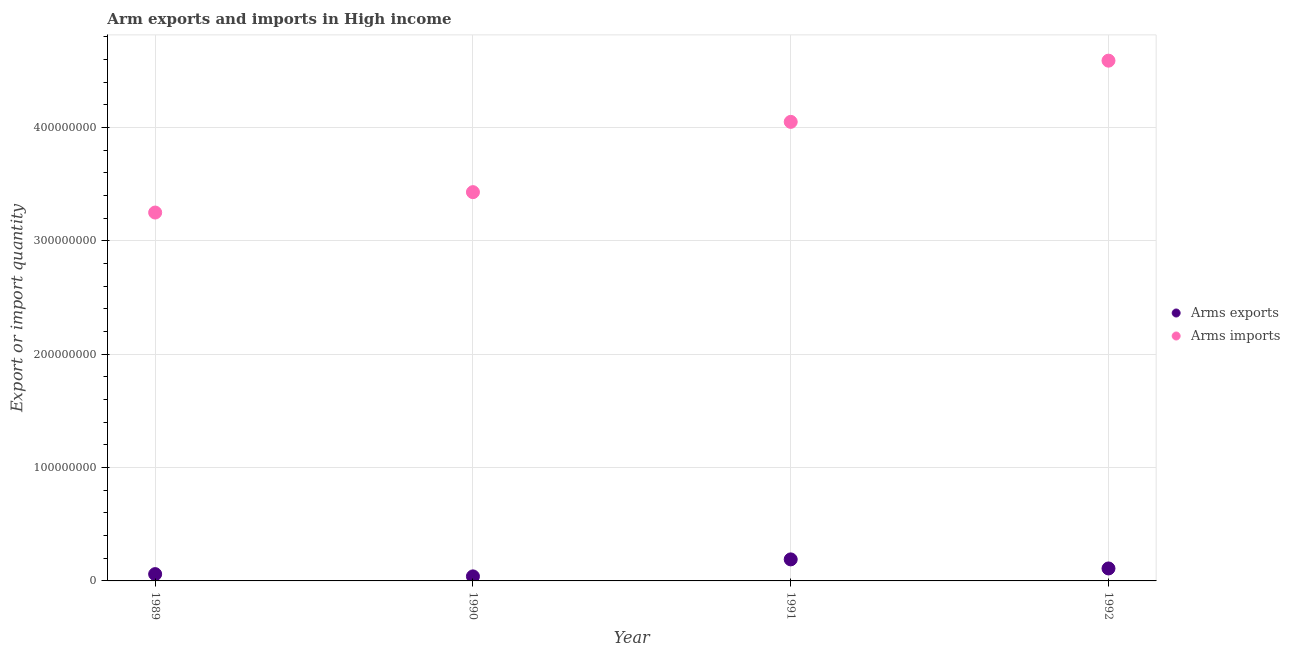Is the number of dotlines equal to the number of legend labels?
Offer a terse response. Yes. What is the arms imports in 1990?
Provide a succinct answer. 3.43e+08. Across all years, what is the maximum arms imports?
Offer a terse response. 4.59e+08. Across all years, what is the minimum arms imports?
Your answer should be very brief. 3.25e+08. In which year was the arms exports minimum?
Provide a short and direct response. 1990. What is the total arms imports in the graph?
Offer a very short reply. 1.53e+09. What is the difference between the arms imports in 1991 and that in 1992?
Your answer should be very brief. -5.40e+07. What is the difference between the arms exports in 1989 and the arms imports in 1992?
Offer a very short reply. -4.53e+08. What is the average arms imports per year?
Keep it short and to the point. 3.83e+08. In the year 1991, what is the difference between the arms imports and arms exports?
Keep it short and to the point. 3.86e+08. In how many years, is the arms exports greater than 340000000?
Give a very brief answer. 0. What is the ratio of the arms imports in 1989 to that in 1992?
Provide a short and direct response. 0.71. Is the arms exports in 1990 less than that in 1991?
Provide a succinct answer. Yes. Is the difference between the arms exports in 1989 and 1990 greater than the difference between the arms imports in 1989 and 1990?
Give a very brief answer. Yes. What is the difference between the highest and the lowest arms imports?
Keep it short and to the point. 1.34e+08. Does the arms imports monotonically increase over the years?
Your answer should be very brief. Yes. What is the difference between two consecutive major ticks on the Y-axis?
Your answer should be compact. 1.00e+08. Are the values on the major ticks of Y-axis written in scientific E-notation?
Give a very brief answer. No. Does the graph contain grids?
Your answer should be very brief. Yes. How are the legend labels stacked?
Provide a succinct answer. Vertical. What is the title of the graph?
Offer a terse response. Arm exports and imports in High income. Does "Food" appear as one of the legend labels in the graph?
Provide a succinct answer. No. What is the label or title of the Y-axis?
Your response must be concise. Export or import quantity. What is the Export or import quantity of Arms imports in 1989?
Make the answer very short. 3.25e+08. What is the Export or import quantity of Arms imports in 1990?
Ensure brevity in your answer.  3.43e+08. What is the Export or import quantity in Arms exports in 1991?
Offer a very short reply. 1.90e+07. What is the Export or import quantity in Arms imports in 1991?
Keep it short and to the point. 4.05e+08. What is the Export or import quantity of Arms exports in 1992?
Your response must be concise. 1.10e+07. What is the Export or import quantity of Arms imports in 1992?
Offer a terse response. 4.59e+08. Across all years, what is the maximum Export or import quantity of Arms exports?
Your response must be concise. 1.90e+07. Across all years, what is the maximum Export or import quantity in Arms imports?
Keep it short and to the point. 4.59e+08. Across all years, what is the minimum Export or import quantity in Arms imports?
Offer a terse response. 3.25e+08. What is the total Export or import quantity of Arms exports in the graph?
Your answer should be compact. 4.00e+07. What is the total Export or import quantity of Arms imports in the graph?
Give a very brief answer. 1.53e+09. What is the difference between the Export or import quantity of Arms imports in 1989 and that in 1990?
Provide a short and direct response. -1.80e+07. What is the difference between the Export or import quantity of Arms exports in 1989 and that in 1991?
Make the answer very short. -1.30e+07. What is the difference between the Export or import quantity of Arms imports in 1989 and that in 1991?
Give a very brief answer. -8.00e+07. What is the difference between the Export or import quantity in Arms exports in 1989 and that in 1992?
Your answer should be compact. -5.00e+06. What is the difference between the Export or import quantity in Arms imports in 1989 and that in 1992?
Your answer should be very brief. -1.34e+08. What is the difference between the Export or import quantity in Arms exports in 1990 and that in 1991?
Offer a terse response. -1.50e+07. What is the difference between the Export or import quantity of Arms imports in 1990 and that in 1991?
Provide a short and direct response. -6.20e+07. What is the difference between the Export or import quantity of Arms exports in 1990 and that in 1992?
Your answer should be very brief. -7.00e+06. What is the difference between the Export or import quantity in Arms imports in 1990 and that in 1992?
Provide a succinct answer. -1.16e+08. What is the difference between the Export or import quantity in Arms exports in 1991 and that in 1992?
Give a very brief answer. 8.00e+06. What is the difference between the Export or import quantity in Arms imports in 1991 and that in 1992?
Provide a succinct answer. -5.40e+07. What is the difference between the Export or import quantity in Arms exports in 1989 and the Export or import quantity in Arms imports in 1990?
Your answer should be compact. -3.37e+08. What is the difference between the Export or import quantity in Arms exports in 1989 and the Export or import quantity in Arms imports in 1991?
Ensure brevity in your answer.  -3.99e+08. What is the difference between the Export or import quantity of Arms exports in 1989 and the Export or import quantity of Arms imports in 1992?
Provide a short and direct response. -4.53e+08. What is the difference between the Export or import quantity of Arms exports in 1990 and the Export or import quantity of Arms imports in 1991?
Give a very brief answer. -4.01e+08. What is the difference between the Export or import quantity of Arms exports in 1990 and the Export or import quantity of Arms imports in 1992?
Offer a terse response. -4.55e+08. What is the difference between the Export or import quantity of Arms exports in 1991 and the Export or import quantity of Arms imports in 1992?
Your response must be concise. -4.40e+08. What is the average Export or import quantity of Arms imports per year?
Make the answer very short. 3.83e+08. In the year 1989, what is the difference between the Export or import quantity in Arms exports and Export or import quantity in Arms imports?
Your answer should be very brief. -3.19e+08. In the year 1990, what is the difference between the Export or import quantity of Arms exports and Export or import quantity of Arms imports?
Your answer should be very brief. -3.39e+08. In the year 1991, what is the difference between the Export or import quantity of Arms exports and Export or import quantity of Arms imports?
Keep it short and to the point. -3.86e+08. In the year 1992, what is the difference between the Export or import quantity of Arms exports and Export or import quantity of Arms imports?
Provide a succinct answer. -4.48e+08. What is the ratio of the Export or import quantity of Arms imports in 1989 to that in 1990?
Ensure brevity in your answer.  0.95. What is the ratio of the Export or import quantity of Arms exports in 1989 to that in 1991?
Your answer should be very brief. 0.32. What is the ratio of the Export or import quantity of Arms imports in 1989 to that in 1991?
Offer a terse response. 0.8. What is the ratio of the Export or import quantity in Arms exports in 1989 to that in 1992?
Offer a terse response. 0.55. What is the ratio of the Export or import quantity in Arms imports in 1989 to that in 1992?
Make the answer very short. 0.71. What is the ratio of the Export or import quantity in Arms exports in 1990 to that in 1991?
Ensure brevity in your answer.  0.21. What is the ratio of the Export or import quantity of Arms imports in 1990 to that in 1991?
Make the answer very short. 0.85. What is the ratio of the Export or import quantity of Arms exports in 1990 to that in 1992?
Your answer should be very brief. 0.36. What is the ratio of the Export or import quantity of Arms imports in 1990 to that in 1992?
Keep it short and to the point. 0.75. What is the ratio of the Export or import quantity in Arms exports in 1991 to that in 1992?
Keep it short and to the point. 1.73. What is the ratio of the Export or import quantity in Arms imports in 1991 to that in 1992?
Your answer should be very brief. 0.88. What is the difference between the highest and the second highest Export or import quantity in Arms exports?
Your answer should be compact. 8.00e+06. What is the difference between the highest and the second highest Export or import quantity in Arms imports?
Provide a short and direct response. 5.40e+07. What is the difference between the highest and the lowest Export or import quantity in Arms exports?
Keep it short and to the point. 1.50e+07. What is the difference between the highest and the lowest Export or import quantity of Arms imports?
Your response must be concise. 1.34e+08. 